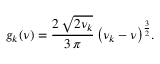Convert formula to latex. <formula><loc_0><loc_0><loc_500><loc_500>g _ { k } ( \nu ) = \frac { 2 \, { \sqrt { 2 \nu _ { k } } } } { 3 \, \pi } \, { \left ( \nu _ { k } - \nu \right ) } ^ { \frac { 3 } { 2 } } .</formula> 